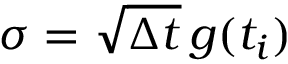Convert formula to latex. <formula><loc_0><loc_0><loc_500><loc_500>\sigma = \sqrt { \Delta t } \, g ( t _ { i } )</formula> 